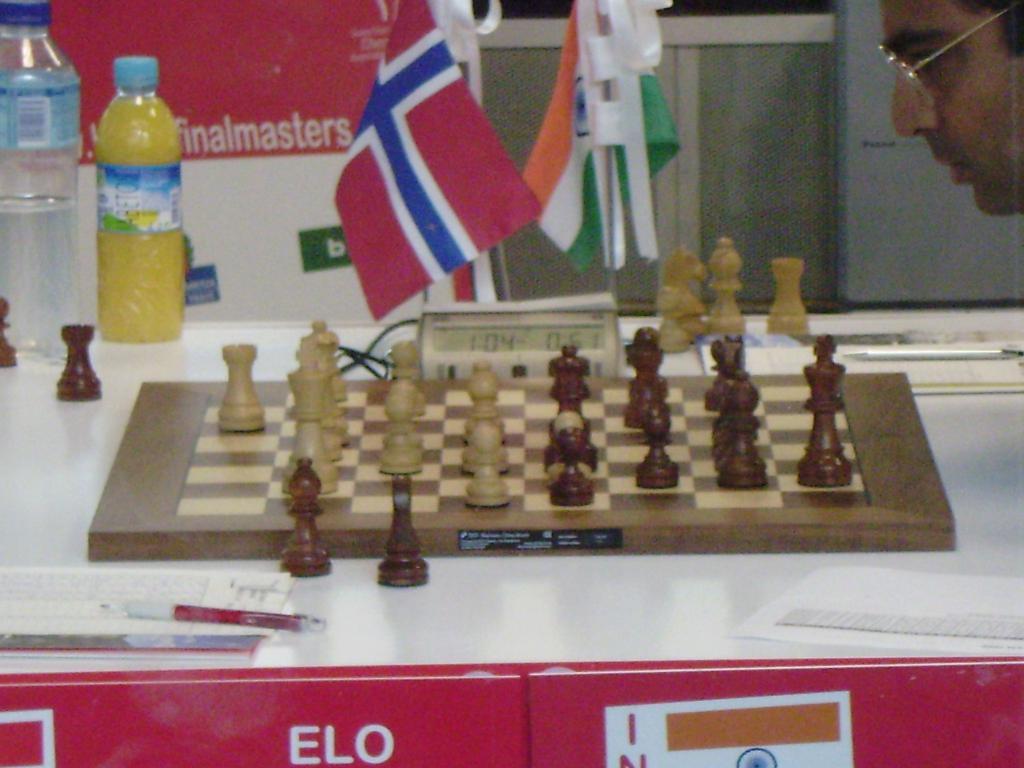What does the clock say?
Make the answer very short. 1:04. What is advertised left of center on the bottom?
Provide a short and direct response. Elo. 